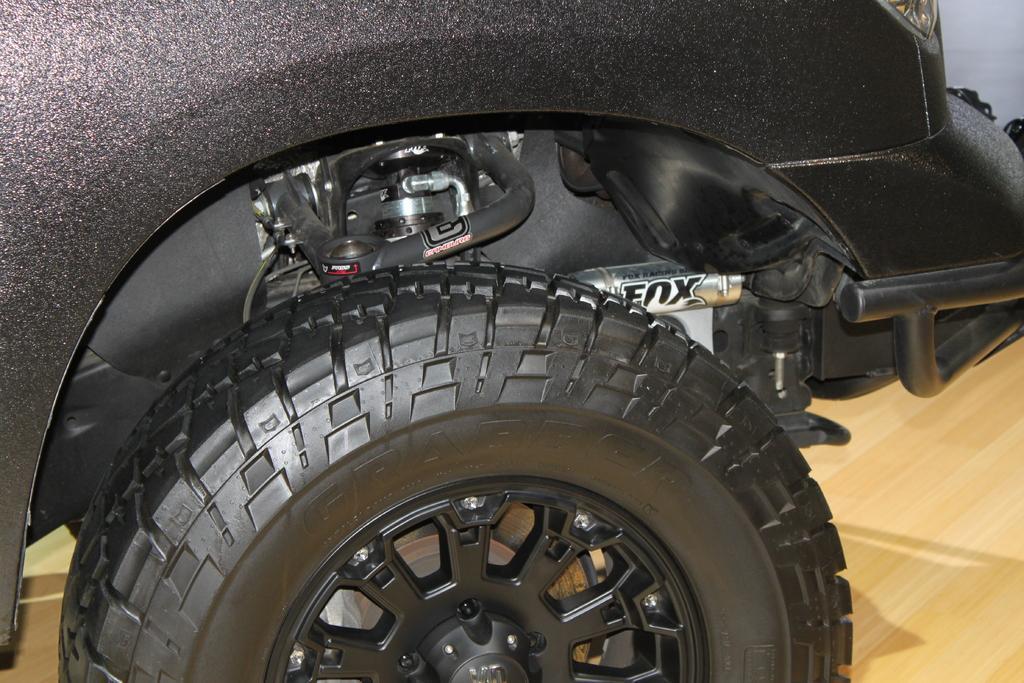Please provide a concise description of this image. In this image we can see a part of a car and a tire which is placed on the surface. 